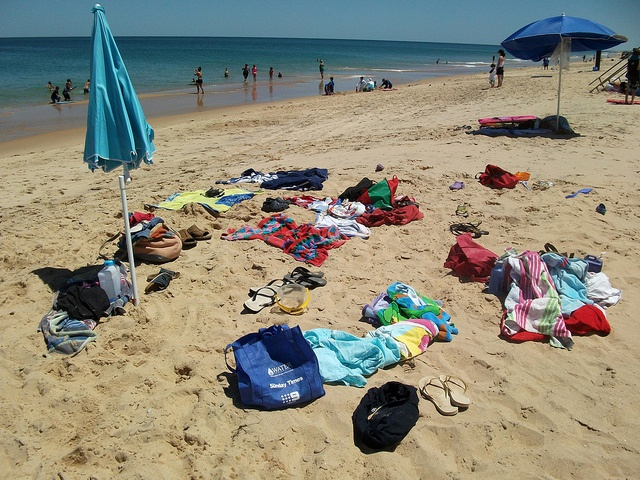Describe the objects in this image and their specific colors. I can see umbrella in teal, blue, and darkblue tones, handbag in teal, navy, blue, and gray tones, umbrella in teal, black, blue, navy, and gray tones, handbag in teal, black, gray, darkgray, and tan tones, and people in teal, gray, black, and darkgray tones in this image. 